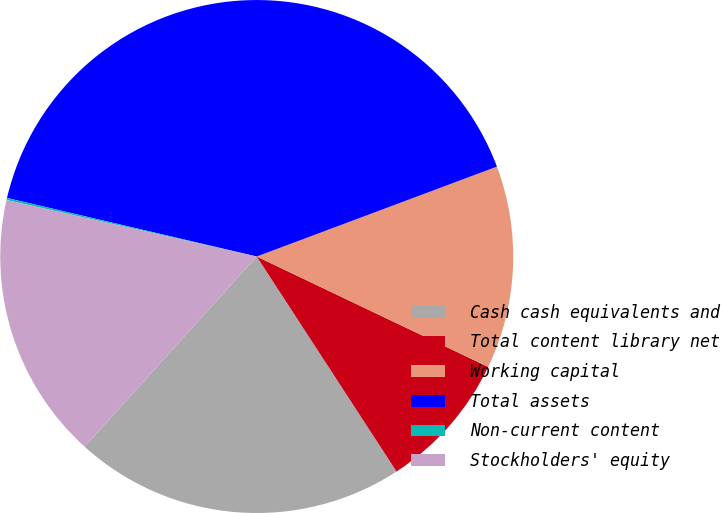Convert chart. <chart><loc_0><loc_0><loc_500><loc_500><pie_chart><fcel>Cash cash equivalents and<fcel>Total content library net<fcel>Working capital<fcel>Total assets<fcel>Non-current content<fcel>Stockholders' equity<nl><fcel>20.88%<fcel>8.74%<fcel>12.78%<fcel>40.63%<fcel>0.13%<fcel>16.83%<nl></chart> 